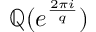<formula> <loc_0><loc_0><loc_500><loc_500>\mathbb { Q } ( e ^ { \frac { 2 \pi i } { q } } )</formula> 